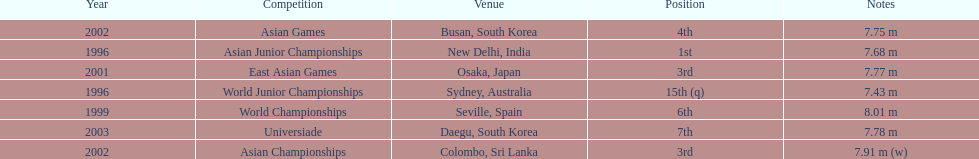How many competitions did he place in the top three? 3. 